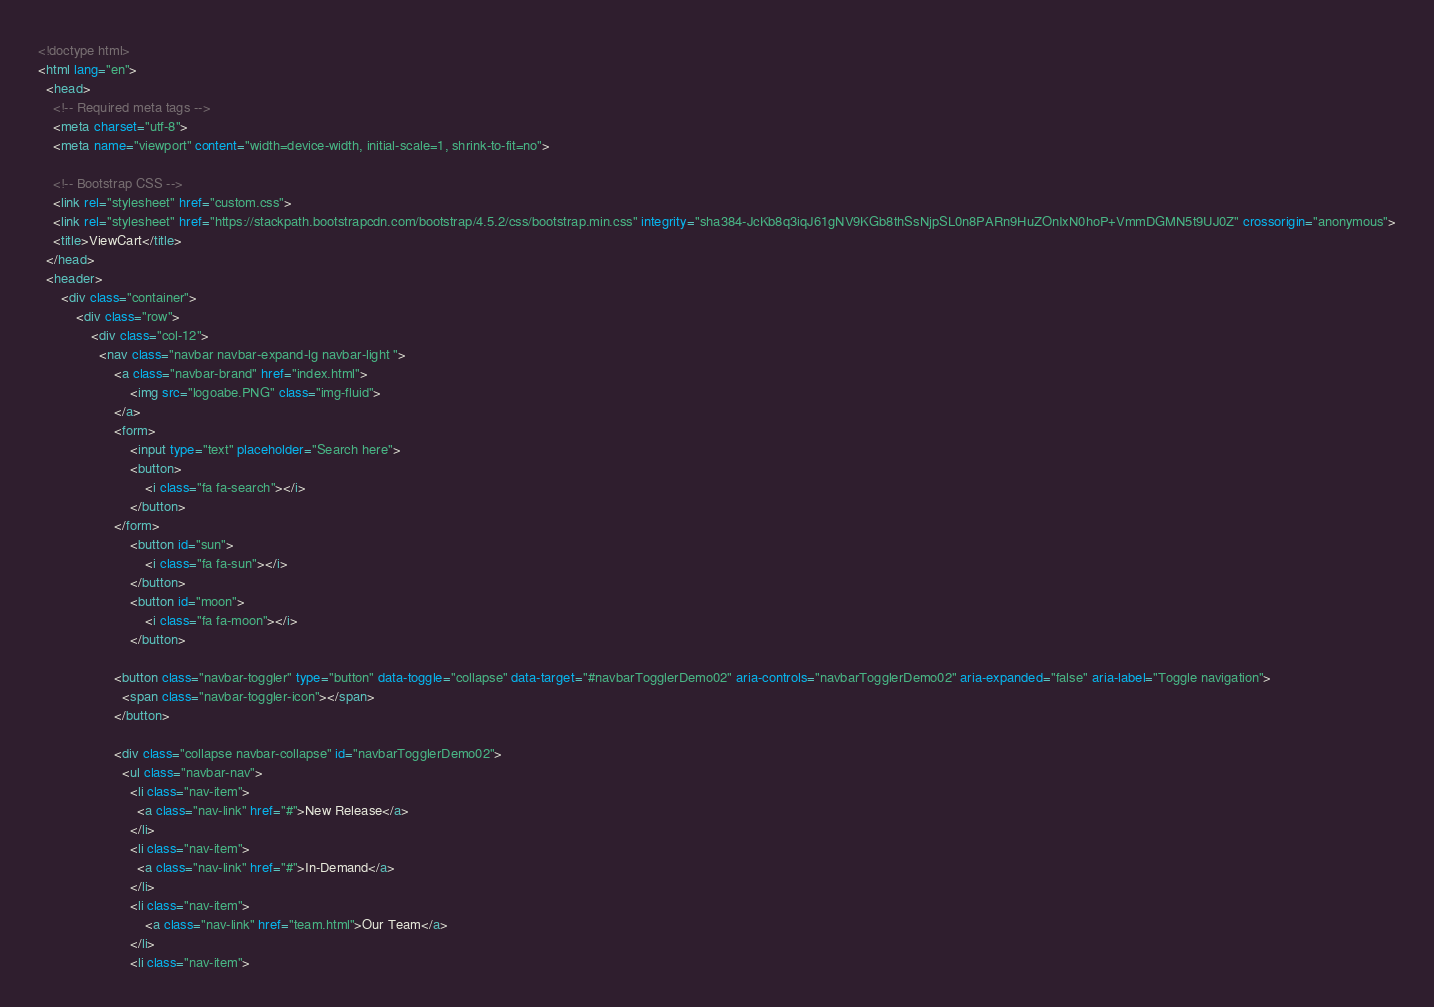<code> <loc_0><loc_0><loc_500><loc_500><_HTML_><!doctype html>
<html lang="en">
  <head>
    <!-- Required meta tags -->
    <meta charset="utf-8">
    <meta name="viewport" content="width=device-width, initial-scale=1, shrink-to-fit=no">

    <!-- Bootstrap CSS -->
    <link rel="stylesheet" href="custom.css">
    <link rel="stylesheet" href="https://stackpath.bootstrapcdn.com/bootstrap/4.5.2/css/bootstrap.min.css" integrity="sha384-JcKb8q3iqJ61gNV9KGb8thSsNjpSL0n8PARn9HuZOnIxN0hoP+VmmDGMN5t9UJ0Z" crossorigin="anonymous">
    <title>ViewCart</title>
  </head>
  <header>
      <div class="container">
          <div class="row">
              <div class="col-12">
                <nav class="navbar navbar-expand-lg navbar-light ">
                    <a class="navbar-brand" href="index.html">
                        <img src="logoabe.PNG" class="img-fluid">
                    </a>
                    <form>
                        <input type="text" placeholder="Search here">
                        <button>
                            <i class="fa fa-search"></i>
                        </button>
                    </form>
                        <button id="sun">
                            <i class="fa fa-sun"></i>
                        </button>
                        <button id="moon">
                            <i class="fa fa-moon"></i>
                        </button>
                    
                    <button class="navbar-toggler" type="button" data-toggle="collapse" data-target="#navbarTogglerDemo02" aria-controls="navbarTogglerDemo02" aria-expanded="false" aria-label="Toggle navigation">
                      <span class="navbar-toggler-icon"></span>
                    </button>
                  
                    <div class="collapse navbar-collapse" id="navbarTogglerDemo02">
                      <ul class="navbar-nav">
                        <li class="nav-item">
                          <a class="nav-link" href="#">New Release</a>
                        </li>
                        <li class="nav-item">
                          <a class="nav-link" href="#">In-Demand</a>
                        </li>
                        <li class="nav-item">
                            <a class="nav-link" href="team.html">Our Team</a>
                        </li>
                        <li class="nav-item"></code> 